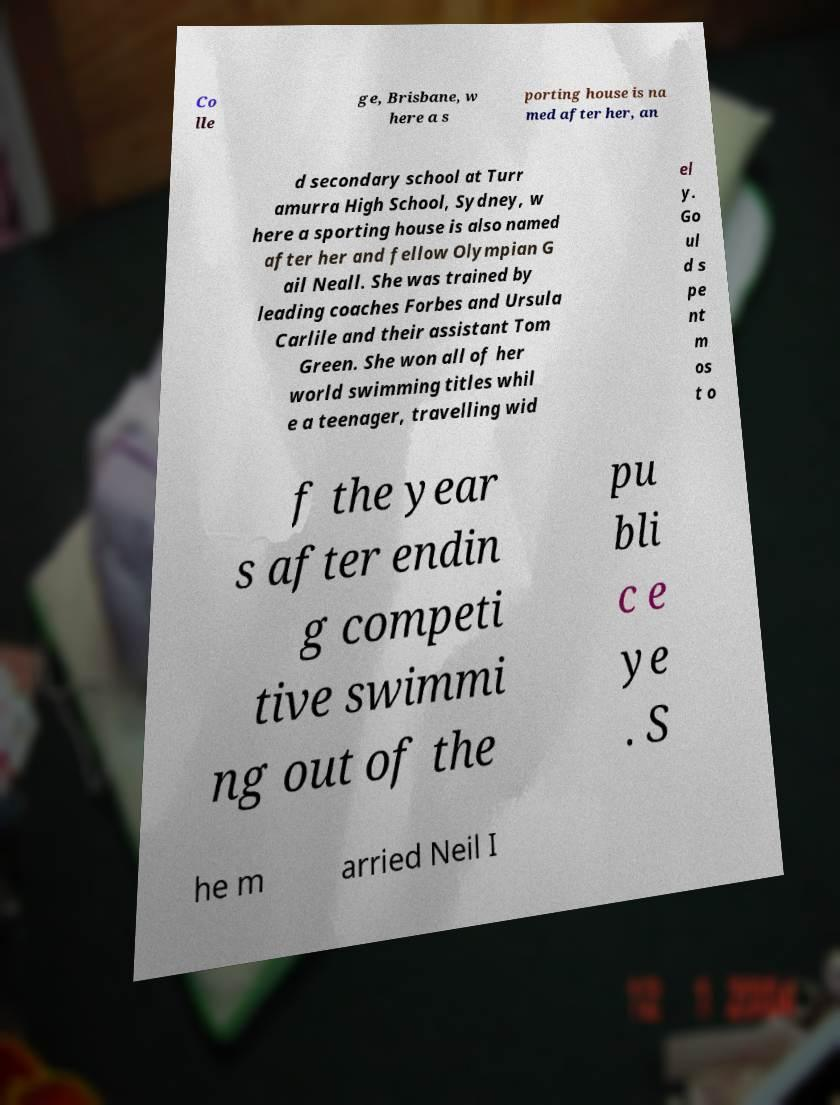Please identify and transcribe the text found in this image. Co lle ge, Brisbane, w here a s porting house is na med after her, an d secondary school at Turr amurra High School, Sydney, w here a sporting house is also named after her and fellow Olympian G ail Neall. She was trained by leading coaches Forbes and Ursula Carlile and their assistant Tom Green. She won all of her world swimming titles whil e a teenager, travelling wid el y. Go ul d s pe nt m os t o f the year s after endin g competi tive swimmi ng out of the pu bli c e ye . S he m arried Neil I 